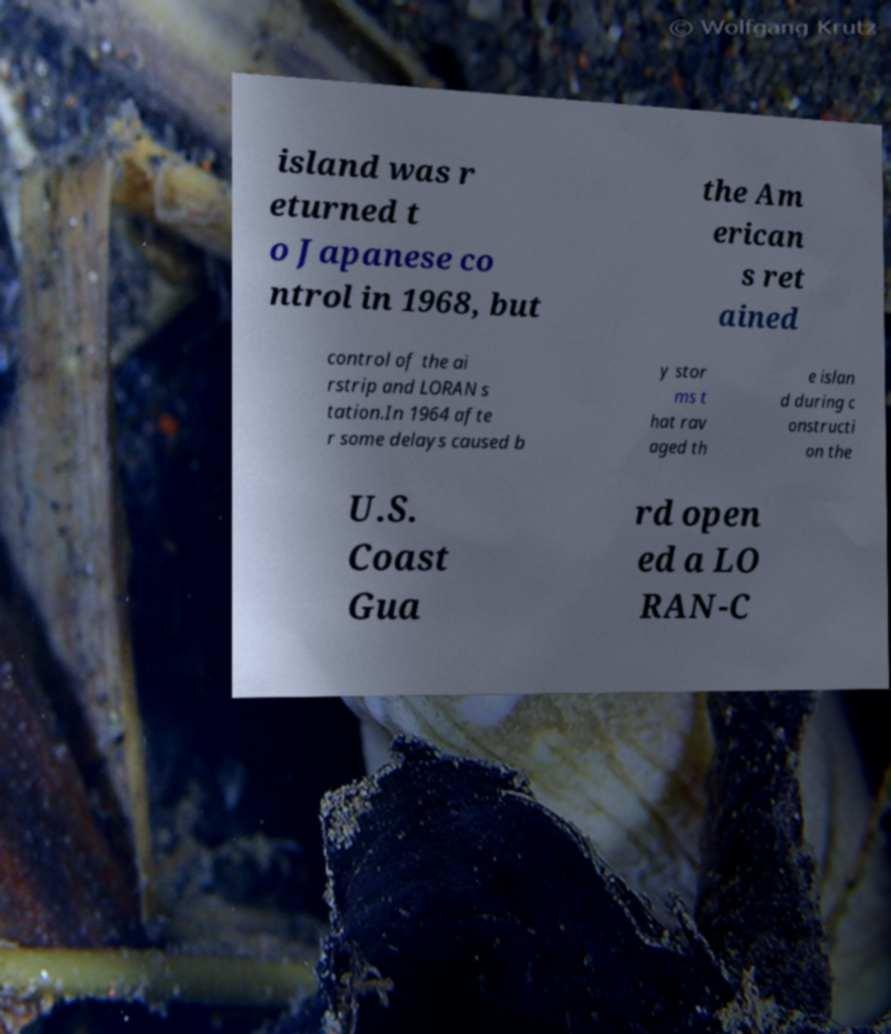There's text embedded in this image that I need extracted. Can you transcribe it verbatim? island was r eturned t o Japanese co ntrol in 1968, but the Am erican s ret ained control of the ai rstrip and LORAN s tation.In 1964 afte r some delays caused b y stor ms t hat rav aged th e islan d during c onstructi on the U.S. Coast Gua rd open ed a LO RAN-C 